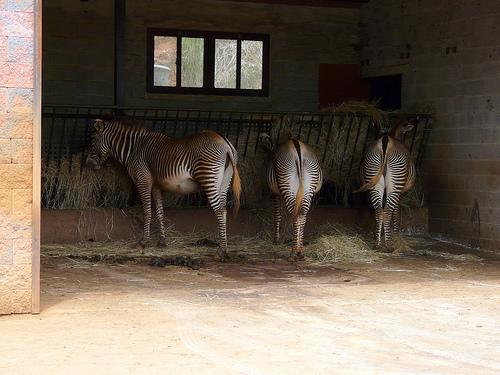Please enumerate the zebras and illustrate their actions. There are 3 zebras, each of them engaged in hay consumption. Identify the primary object in the image and state its activity. Three zebras are the main focus, and they are eating hay. Briefly explain what the zebras in the image are doing. The zebras in the image are feeding on hay. Can you recognize the chief fauna in the image and inform us of their conduct? The chief fauna are zebras, engaging in the consumption of hay. Specify the main animal in the photo and describe its ongoing activity. The main animal is the zebra, which is currently involved in eating hay. Mention the predominant animal and their current behavior. Zebras are the predominant animals and are currently eating hay. What type of animal is primarily in the picture, and what are they consuming? The primary animals are zebras, and they are eating hay. In the image, what is the main species, and what are they partaking in? The main species is zebra, and they are partaking in eating hay. What is the primary content of the image, and what is happening with it? The primary content is a group of three zebras, and they are all eating hay. Count the number of zebras in the image and describe their actions. There are three zebras, and they are all eating hay. 